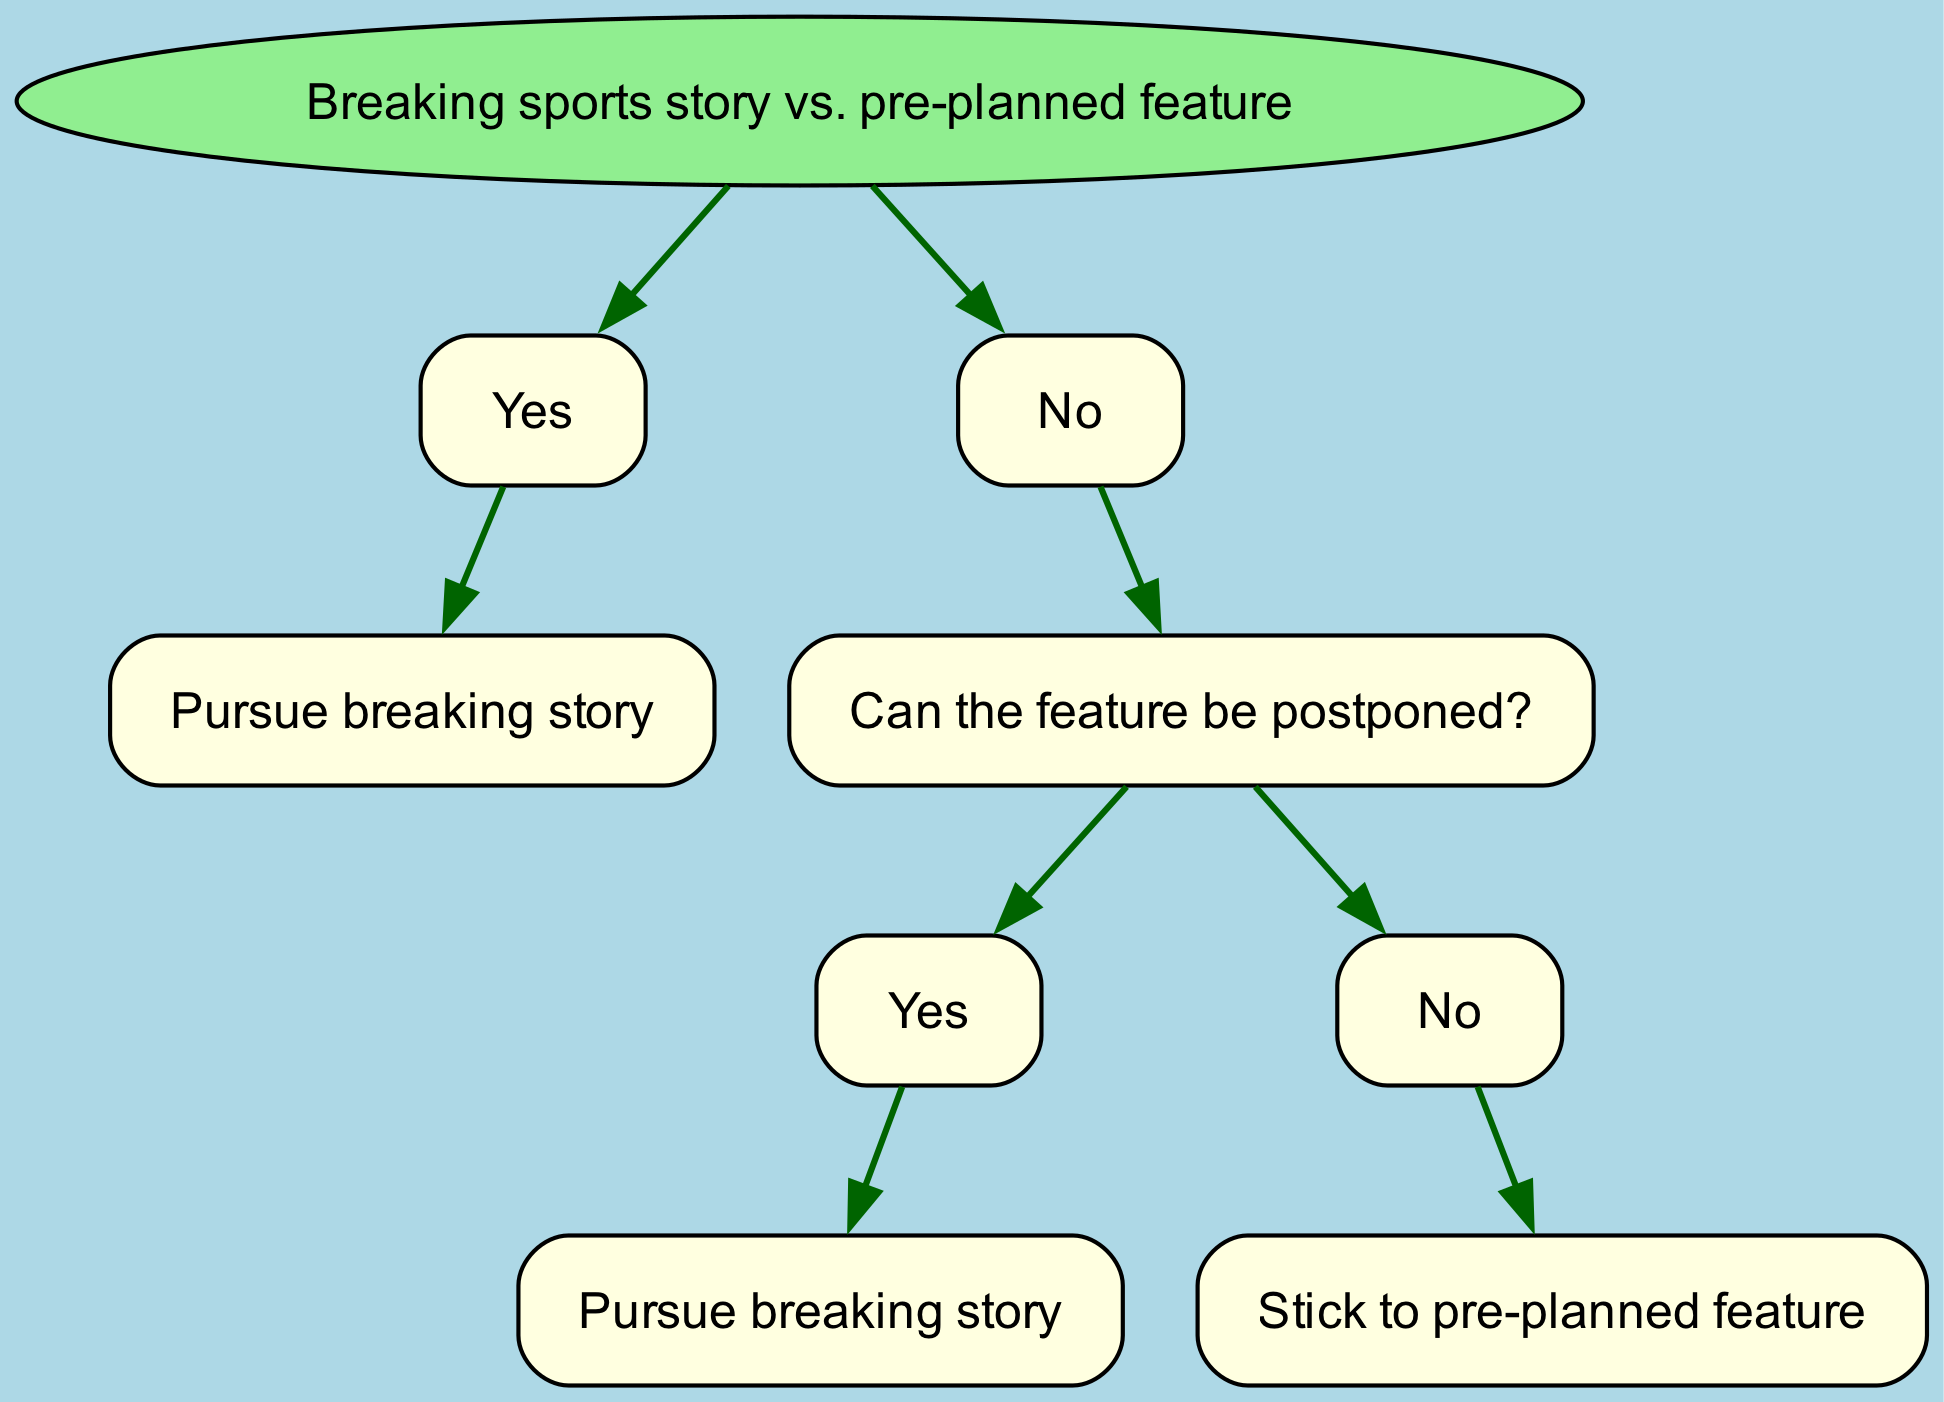What is the root node of the decision tree? The root node is the starting point of the decision tree, indicating the main decision to be made. In this case, it asks whether to pursue a breaking sports story or stick to a pre-planned feature article.
Answer: Breaking sports story vs. pre-planned feature How many total nodes are in the diagram? Counting the root and all child nodes, there are a total of 9 nodes in the diagram. These include the root and all subsequent questions and decisions.
Answer: 9 What happens if the breaking story is about a major WV team? If the breaking story is about a major WV team, the flow goes directly to the action of pursuing the breaking story without any further questions or decisions.
Answer: Pursue breaking story If the breaking story is not about a major WV team and the feature can be postponed, what is the next action? In this scenario, if the feature can be postponed, the next action is to pursue the breaking story. This indicates a preference to pursue new, relevant news over prior commitments.
Answer: Pursue breaking story What should be done if the breaking story is not about a major WV team and the feature cannot be postponed? If the breaking story is not about a major WV team and the feature cannot be postponed, the decision is to stick to the pre-planned feature article. This reinforces commitment to prior planning in the absence of significant news.
Answer: Stick to pre-planned feature What is the first question asked in the decision-making process? The first question asked in the decision process is whether the breaking story is about a major WV team. This is crucial as it determines the direction of subsequent decisions.
Answer: Is the breaking story about a major WV team? What is the relationship between the nodes regarding postponement of the feature? The relationship shows that the ability to postpone the feature influences the decision. If it can be postponed, the tree directs to pursue the breaking story; if not, it leads to sticking with the planned feature.
Answer: Dependency on postponement What is the outcome if both conditions regarding the breaking story and postponement lead to a non-pursuit decision? The outcome in such a scenario is sticking to the pre-planned feature. This reflects that when there’s no urgency or necessity from current events, the original plan takes precedence.
Answer: Stick to pre-planned feature 